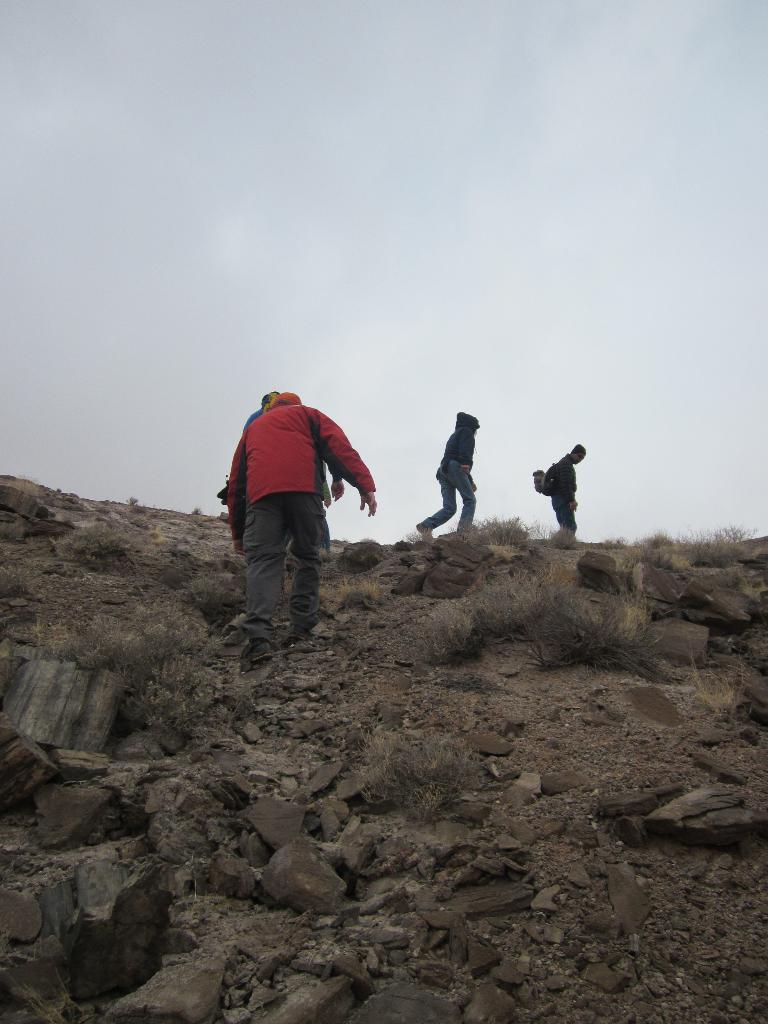Could you give a brief overview of what you see in this image? In the center of the image we can see persons walking on the ground. On the right and left side of the image we can see stones. In the background there are clouds and sky. 